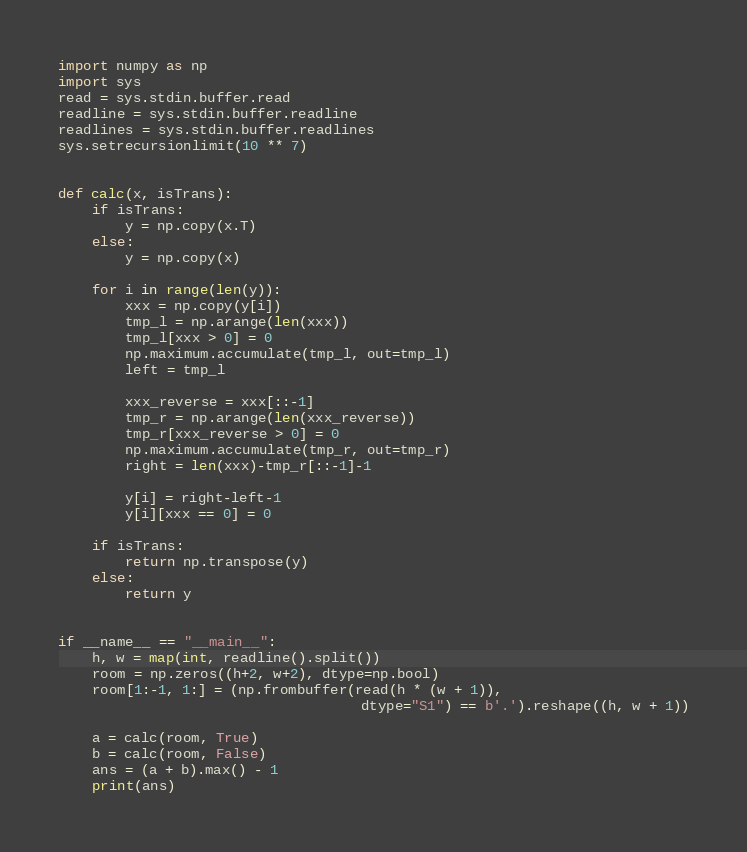Convert code to text. <code><loc_0><loc_0><loc_500><loc_500><_Python_>import numpy as np
import sys
read = sys.stdin.buffer.read
readline = sys.stdin.buffer.readline
readlines = sys.stdin.buffer.readlines
sys.setrecursionlimit(10 ** 7)


def calc(x, isTrans):
    if isTrans:
        y = np.copy(x.T)
    else:
        y = np.copy(x)

    for i in range(len(y)):
        xxx = np.copy(y[i])
        tmp_l = np.arange(len(xxx))
        tmp_l[xxx > 0] = 0
        np.maximum.accumulate(tmp_l, out=tmp_l)
        left = tmp_l

        xxx_reverse = xxx[::-1]
        tmp_r = np.arange(len(xxx_reverse))
        tmp_r[xxx_reverse > 0] = 0
        np.maximum.accumulate(tmp_r, out=tmp_r)
        right = len(xxx)-tmp_r[::-1]-1

        y[i] = right-left-1
        y[i][xxx == 0] = 0

    if isTrans:
        return np.transpose(y)
    else:
        return y


if __name__ == "__main__":
    h, w = map(int, readline().split())
    room = np.zeros((h+2, w+2), dtype=np.bool)
    room[1:-1, 1:] = (np.frombuffer(read(h * (w + 1)),
                                    dtype="S1") == b'.').reshape((h, w + 1))

    a = calc(room, True)
    b = calc(room, False)
    ans = (a + b).max() - 1
    print(ans)
</code> 